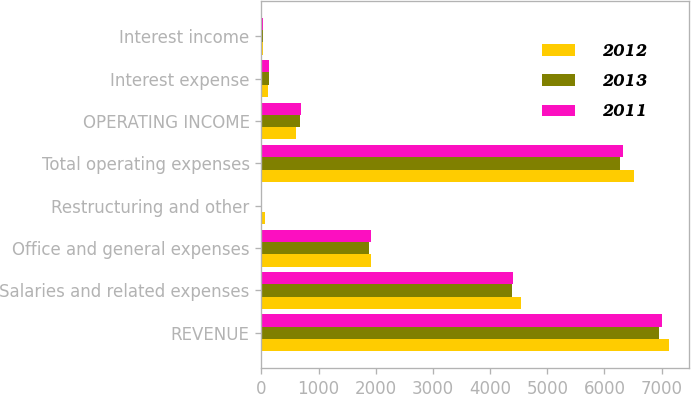<chart> <loc_0><loc_0><loc_500><loc_500><stacked_bar_chart><ecel><fcel>REVENUE<fcel>Salaries and related expenses<fcel>Office and general expenses<fcel>Restructuring and other<fcel>Total operating expenses<fcel>OPERATING INCOME<fcel>Interest expense<fcel>Interest income<nl><fcel>2012<fcel>7122.3<fcel>4545.5<fcel>1917.9<fcel>60.6<fcel>6524<fcel>598.3<fcel>122.7<fcel>24.7<nl><fcel>2013<fcel>6956.2<fcel>4391.9<fcel>1887.2<fcel>1.2<fcel>6277.9<fcel>678.3<fcel>133.5<fcel>29.5<nl><fcel>2011<fcel>7014.6<fcel>4402.1<fcel>1924.3<fcel>1<fcel>6327.4<fcel>687.2<fcel>136.8<fcel>37.8<nl></chart> 